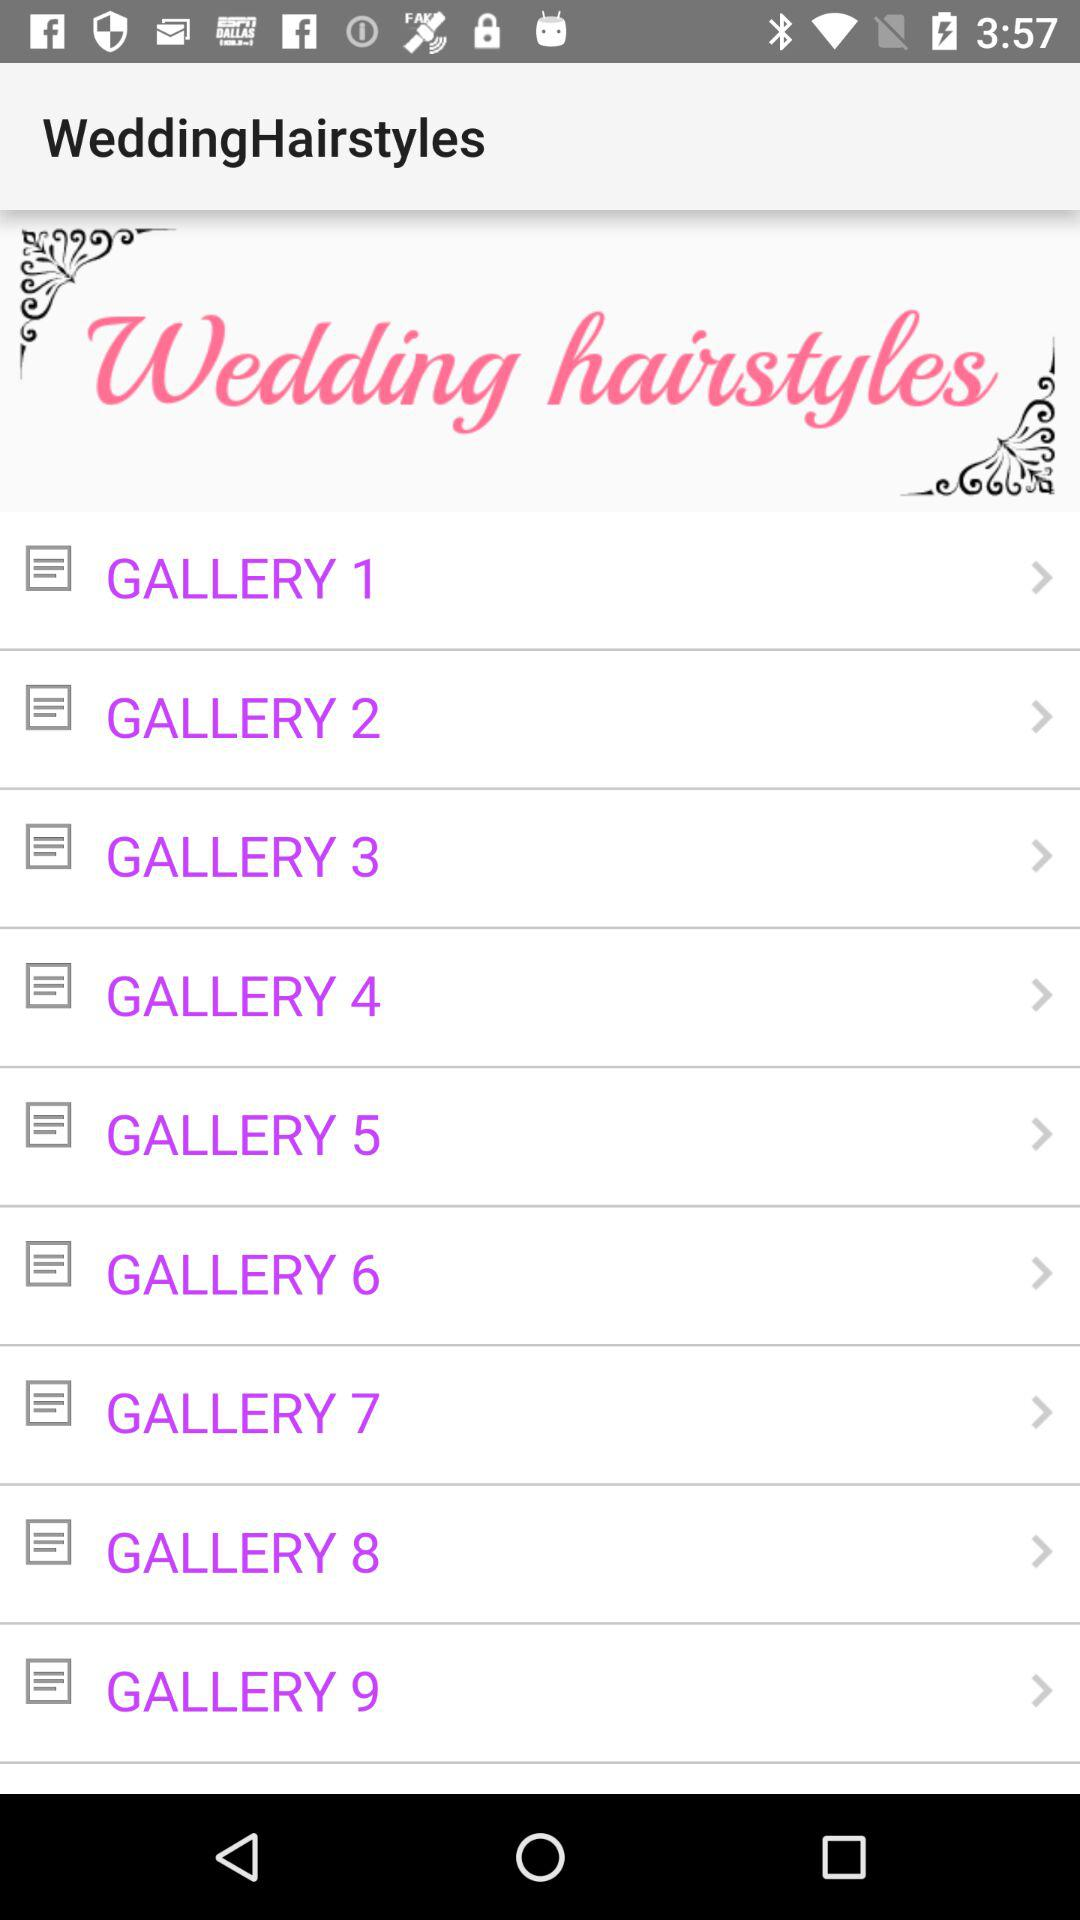How many galleries are there after the first gallery?
Answer the question using a single word or phrase. 8 